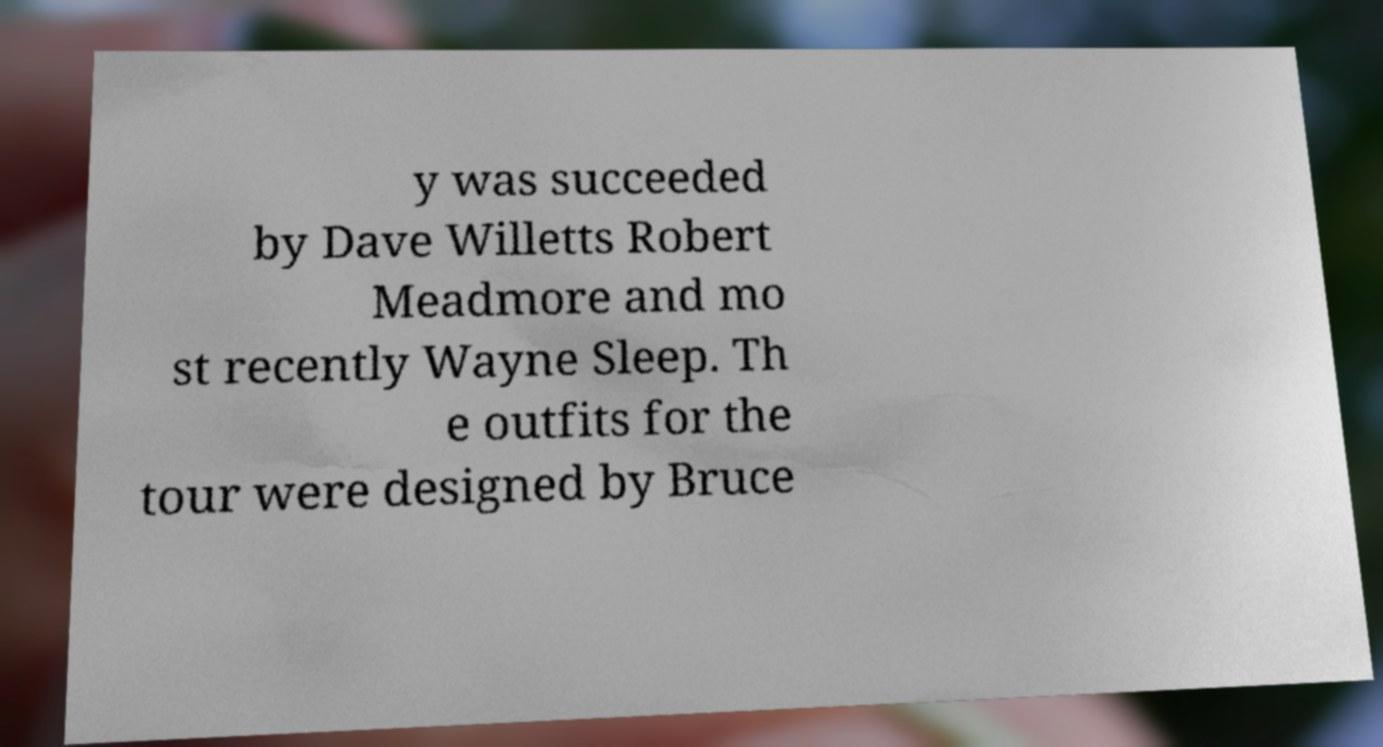For documentation purposes, I need the text within this image transcribed. Could you provide that? y was succeeded by Dave Willetts Robert Meadmore and mo st recently Wayne Sleep. Th e outfits for the tour were designed by Bruce 